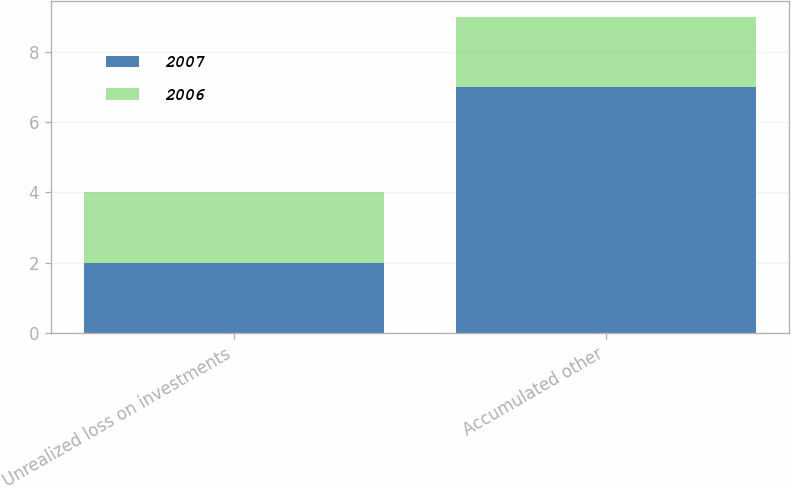<chart> <loc_0><loc_0><loc_500><loc_500><stacked_bar_chart><ecel><fcel>Unrealized loss on investments<fcel>Accumulated other<nl><fcel>2007<fcel>2<fcel>7<nl><fcel>2006<fcel>2<fcel>2<nl></chart> 